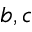<formula> <loc_0><loc_0><loc_500><loc_500>b , c</formula> 